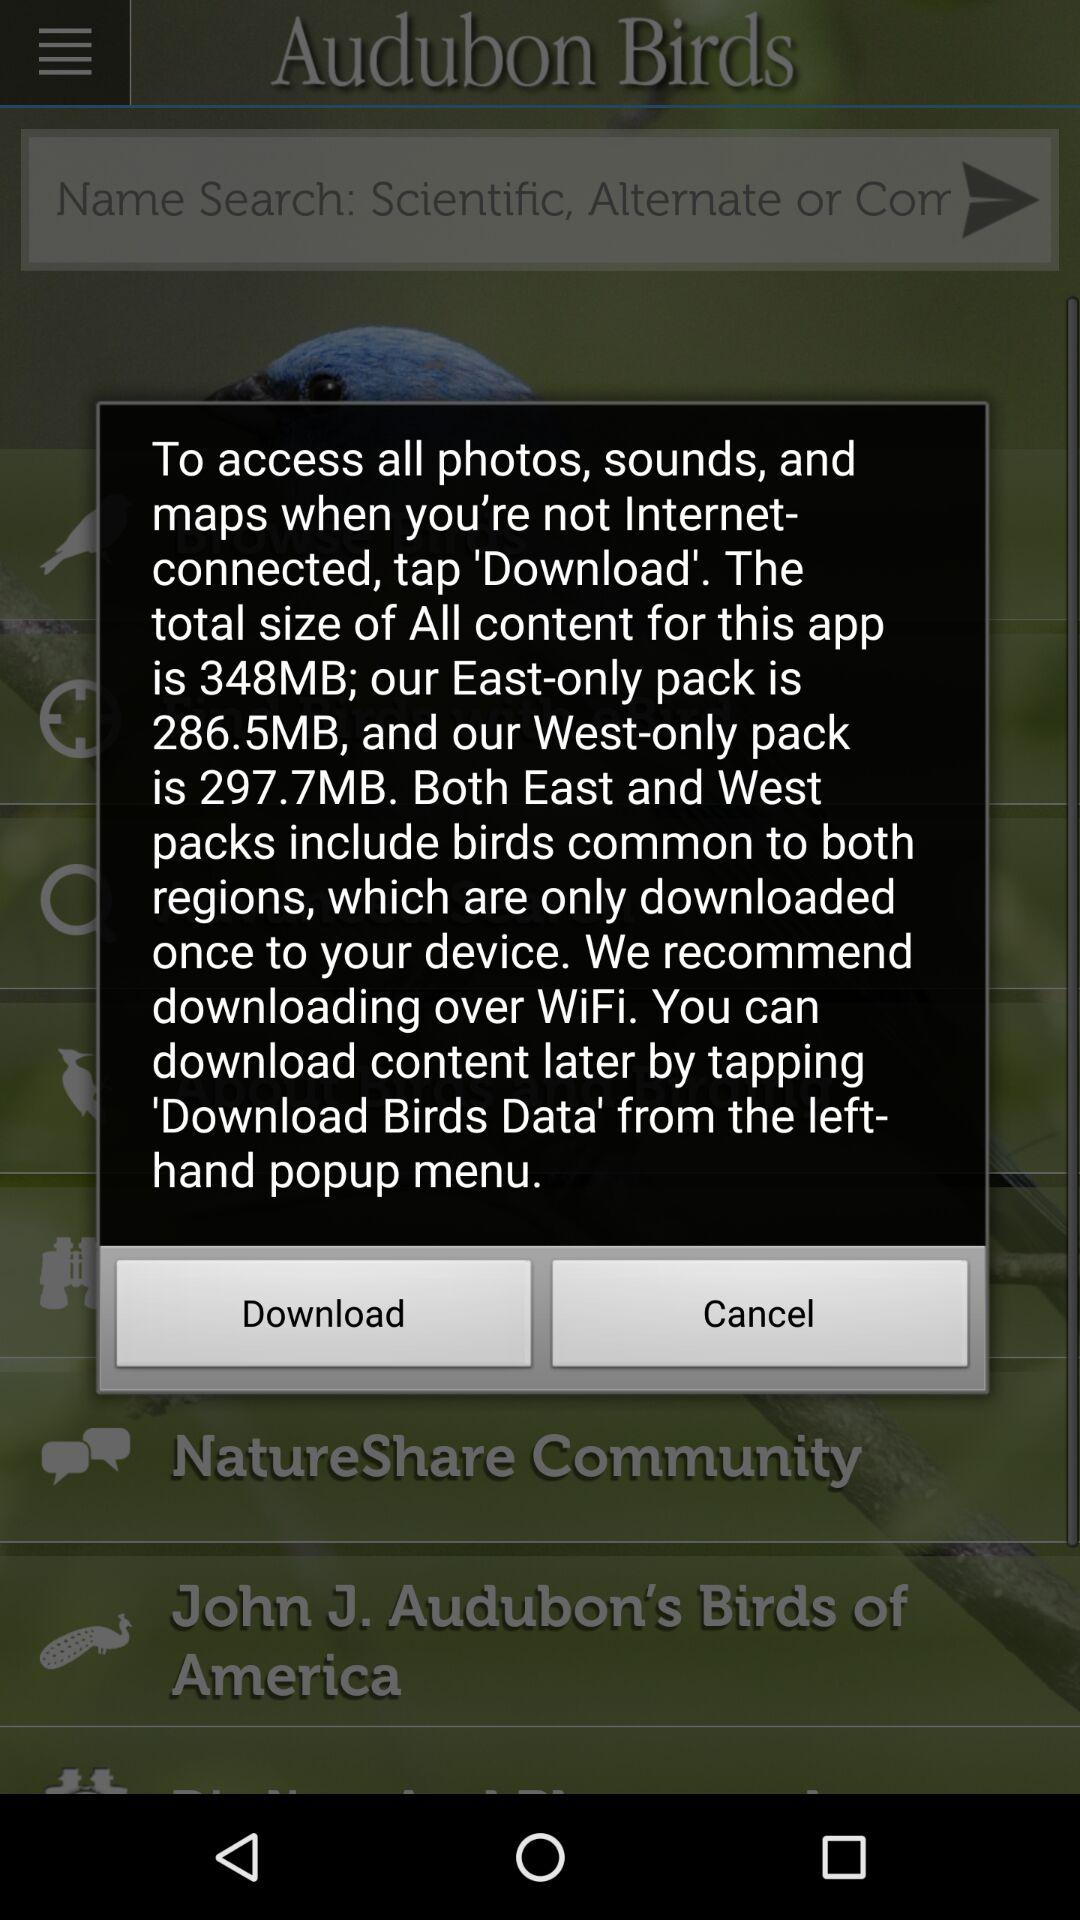How many more megabytes is the West-only pack than the East-only pack?
Answer the question using a single word or phrase. 11.2 